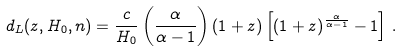<formula> <loc_0><loc_0><loc_500><loc_500>d _ { L } ( z , H _ { 0 } , n ) = \frac { c } { H _ { 0 } } \left ( \frac { \alpha } { \alpha - 1 } \right ) ( 1 + z ) \left [ ( 1 + z ) ^ { \frac { \alpha } { \alpha - 1 } } - 1 \right ] \, .</formula> 